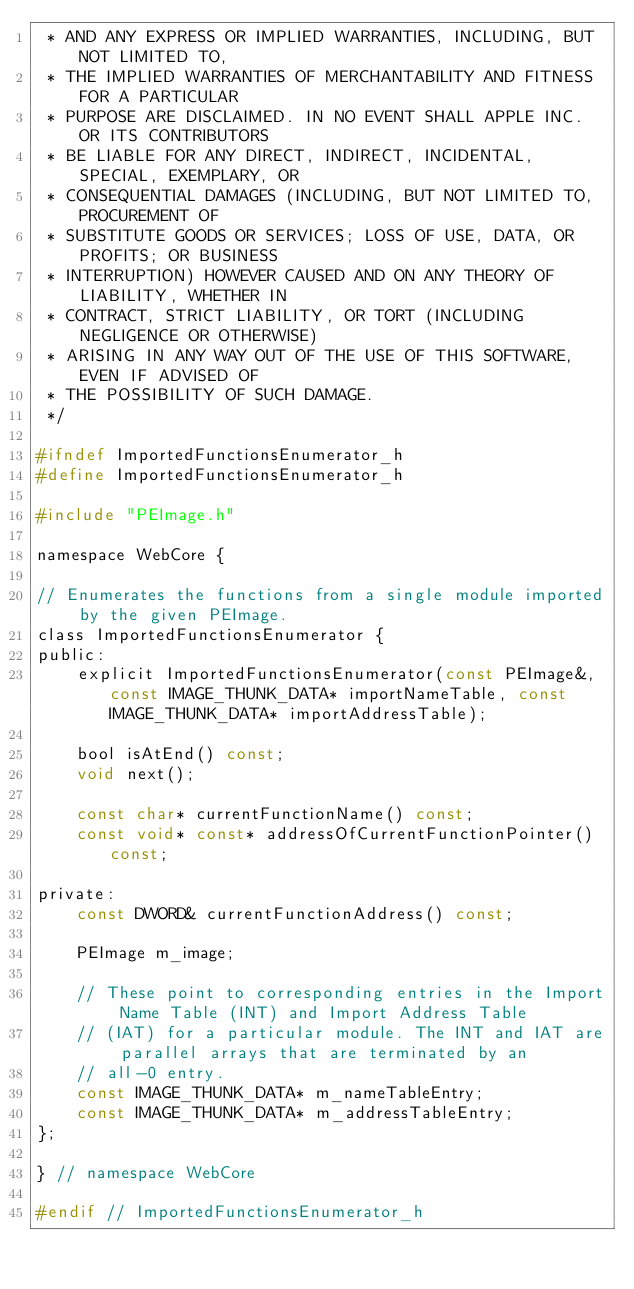Convert code to text. <code><loc_0><loc_0><loc_500><loc_500><_C_> * AND ANY EXPRESS OR IMPLIED WARRANTIES, INCLUDING, BUT NOT LIMITED TO,
 * THE IMPLIED WARRANTIES OF MERCHANTABILITY AND FITNESS FOR A PARTICULAR
 * PURPOSE ARE DISCLAIMED. IN NO EVENT SHALL APPLE INC. OR ITS CONTRIBUTORS
 * BE LIABLE FOR ANY DIRECT, INDIRECT, INCIDENTAL, SPECIAL, EXEMPLARY, OR
 * CONSEQUENTIAL DAMAGES (INCLUDING, BUT NOT LIMITED TO, PROCUREMENT OF
 * SUBSTITUTE GOODS OR SERVICES; LOSS OF USE, DATA, OR PROFITS; OR BUSINESS
 * INTERRUPTION) HOWEVER CAUSED AND ON ANY THEORY OF LIABILITY, WHETHER IN
 * CONTRACT, STRICT LIABILITY, OR TORT (INCLUDING NEGLIGENCE OR OTHERWISE)
 * ARISING IN ANY WAY OUT OF THE USE OF THIS SOFTWARE, EVEN IF ADVISED OF
 * THE POSSIBILITY OF SUCH DAMAGE.
 */

#ifndef ImportedFunctionsEnumerator_h
#define ImportedFunctionsEnumerator_h

#include "PEImage.h"

namespace WebCore {

// Enumerates the functions from a single module imported by the given PEImage.
class ImportedFunctionsEnumerator {
public:
    explicit ImportedFunctionsEnumerator(const PEImage&, const IMAGE_THUNK_DATA* importNameTable, const IMAGE_THUNK_DATA* importAddressTable);

    bool isAtEnd() const;
    void next();

    const char* currentFunctionName() const;
    const void* const* addressOfCurrentFunctionPointer() const;

private:
    const DWORD& currentFunctionAddress() const;

    PEImage m_image;

    // These point to corresponding entries in the Import Name Table (INT) and Import Address Table
    // (IAT) for a particular module. The INT and IAT are parallel arrays that are terminated by an
    // all-0 entry.
    const IMAGE_THUNK_DATA* m_nameTableEntry;
    const IMAGE_THUNK_DATA* m_addressTableEntry;
};

} // namespace WebCore

#endif // ImportedFunctionsEnumerator_h
</code> 